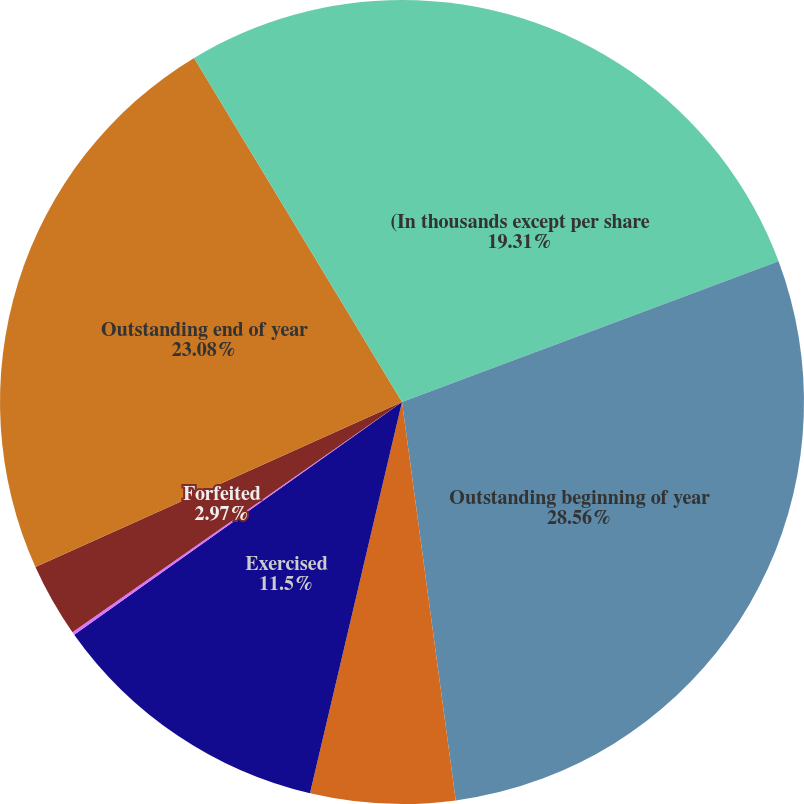Convert chart. <chart><loc_0><loc_0><loc_500><loc_500><pie_chart><fcel>(In thousands except per share<fcel>Outstanding beginning of year<fcel>Granted at fair market value<fcel>Exercised<fcel>Expired<fcel>Forfeited<fcel>Outstanding end of year<fcel>Options exercisable end of<nl><fcel>19.31%<fcel>28.55%<fcel>5.81%<fcel>11.5%<fcel>0.12%<fcel>2.97%<fcel>23.08%<fcel>8.65%<nl></chart> 